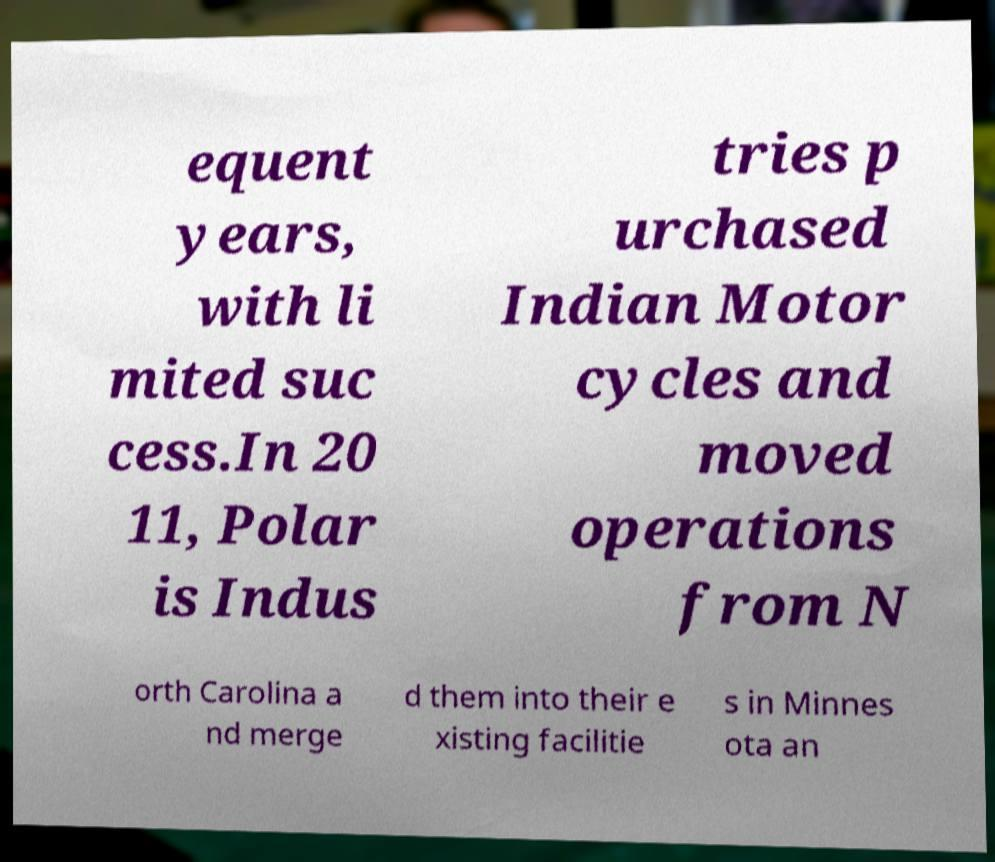What messages or text are displayed in this image? I need them in a readable, typed format. equent years, with li mited suc cess.In 20 11, Polar is Indus tries p urchased Indian Motor cycles and moved operations from N orth Carolina a nd merge d them into their e xisting facilitie s in Minnes ota an 